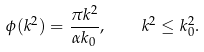Convert formula to latex. <formula><loc_0><loc_0><loc_500><loc_500>\phi ( k ^ { 2 } ) = \frac { \pi k ^ { 2 } } { \alpha k _ { 0 } } , \quad k ^ { 2 } \leq k _ { 0 } ^ { 2 } .</formula> 